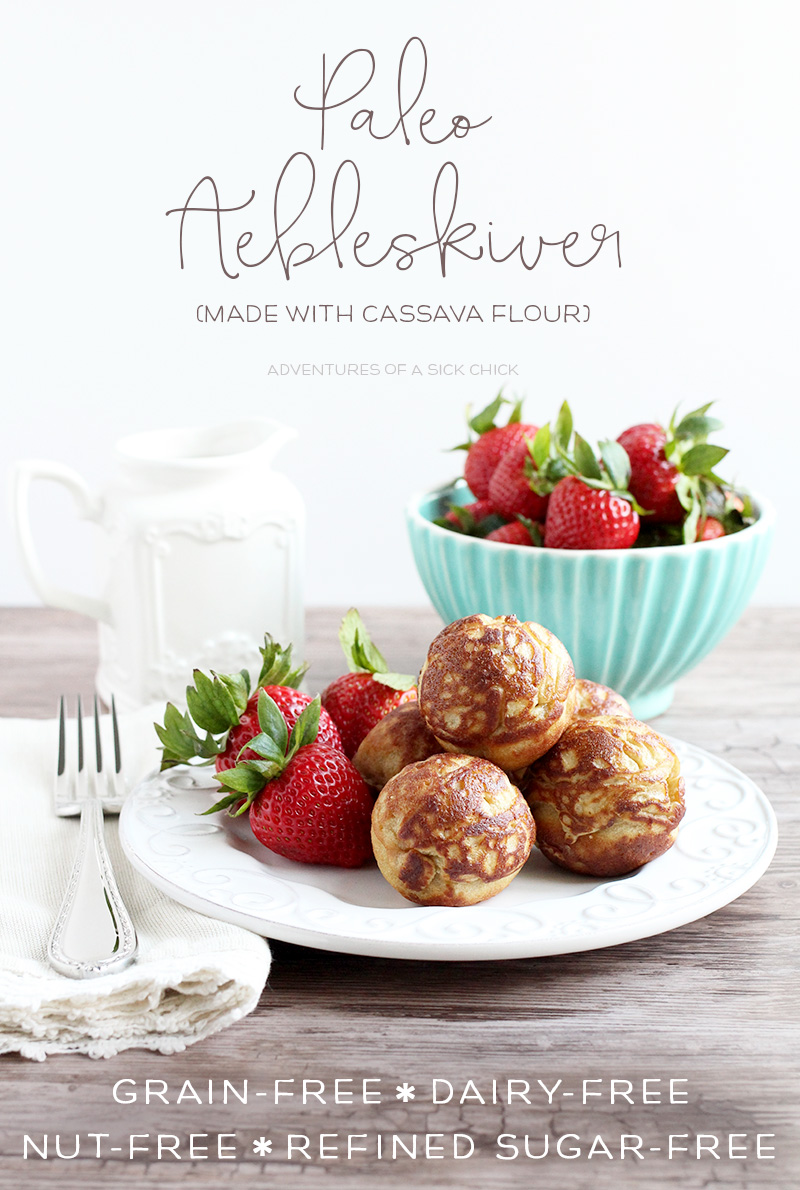Considering the aesthetics of the image, how might the presentation appeal to health-conscious consumers? The presentation of the image is visually appealing and targets health-conscious consumers by emphasizing fresh and natural ingredients. The vibrant, fresh strawberries placed alongside the golden-brown pastries highlight a sense of wholesomeness and freshness. The use of a clean, white plate and the light, airy background further evoke a sense of purity and simplicity, which aligns with the health-focused attributes such as 'grain-free,' 'dairy-free,' 'nut-free,' and 'refined sugar-free.' Additionally, the elegant handwritten-style text adds a touch of sophistication, suggesting that these dietary-friendly pastries are a premium, thoughtful choice for those seeking healthy yet delightful food options. Imagine these pastries are served at a health-focused brunch. What other items might be on the menu to complement these æbleskiver? At a health-focused brunch, these cassava flour æbleskiver would pair beautifully with a variety of other nutritious and delicious menu items. Some complementary dishes might include: 

1. A vibrant avocado and tomato salad, garnished with fresh herbs and a light lemon vinaigrette.
2. Smoothie bowls topped with an assortment of fresh fruits, nuts, seeds, and a drizzle of honey or maple syrup for added sweetness.
3. Grain-free and dairy-free quiches made with a combination of vegetables, lean proteins like turkey or chicken, and a coconut milk or almond milk base.
4. An assortment of fresh-pressed vegetable and fruit juices, like a refreshing cucumber and mint lemonade or a nutrient-packed beetroot and carrot juice blend.
5. Gluten-free granola served with dairy-free yogurt and a side of fresh berries.

These options would provide a balanced, satisfying, and health-conscious brunch experience, highlighting the theme of nutrition and wellness. 